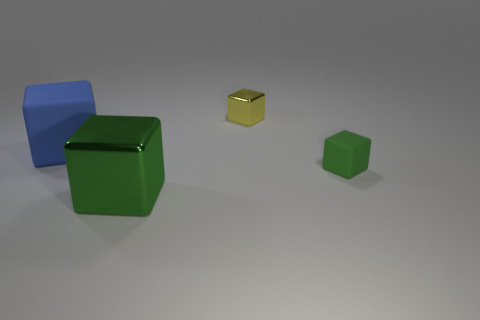Subtract all yellow balls. How many green blocks are left? 2 Subtract all yellow blocks. How many blocks are left? 3 Subtract all tiny green matte blocks. How many blocks are left? 3 Add 2 tiny metallic objects. How many objects exist? 6 Subtract all large blue blocks. Subtract all small yellow shiny balls. How many objects are left? 3 Add 4 green metal cubes. How many green metal cubes are left? 5 Add 1 small metal things. How many small metal things exist? 2 Subtract 0 blue balls. How many objects are left? 4 Subtract all cyan blocks. Subtract all green cylinders. How many blocks are left? 4 